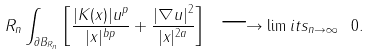Convert formula to latex. <formula><loc_0><loc_0><loc_500><loc_500>R _ { n } \int _ { \partial B _ { R _ { n } } } \left [ \frac { | K ( x ) | u ^ { p } } { | x | ^ { b p } } + \frac { | \nabla u | ^ { 2 } } { | x | ^ { 2 a } } \right ] \ \longrightarrow \lim i t s _ { n \to \infty } \ 0 .</formula> 